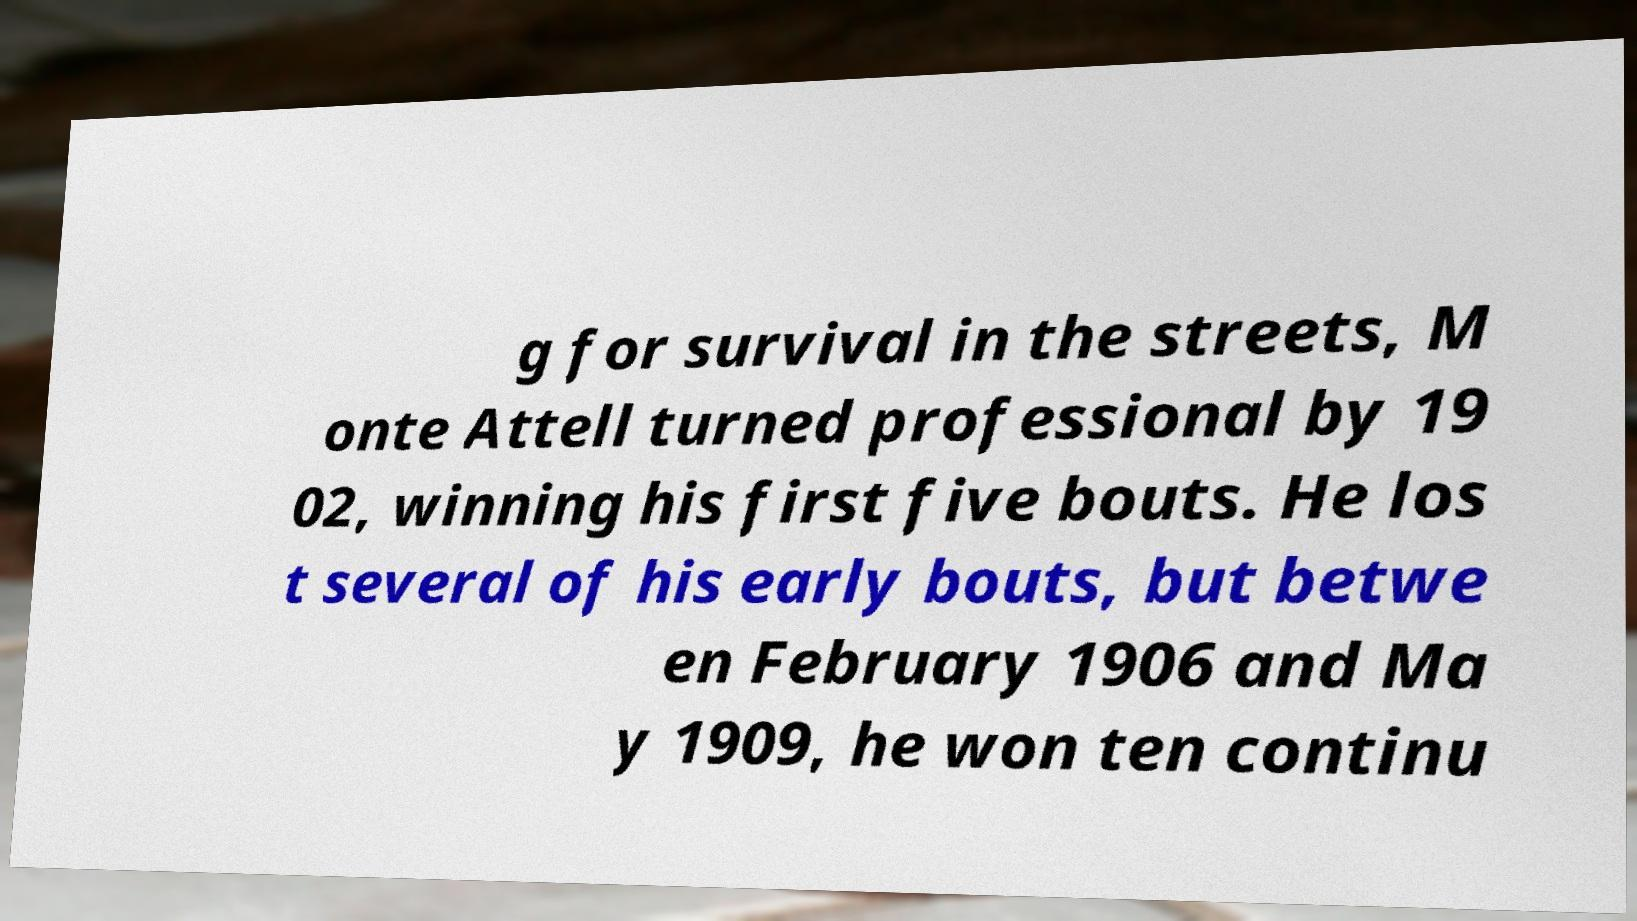Please read and relay the text visible in this image. What does it say? g for survival in the streets, M onte Attell turned professional by 19 02, winning his first five bouts. He los t several of his early bouts, but betwe en February 1906 and Ma y 1909, he won ten continu 